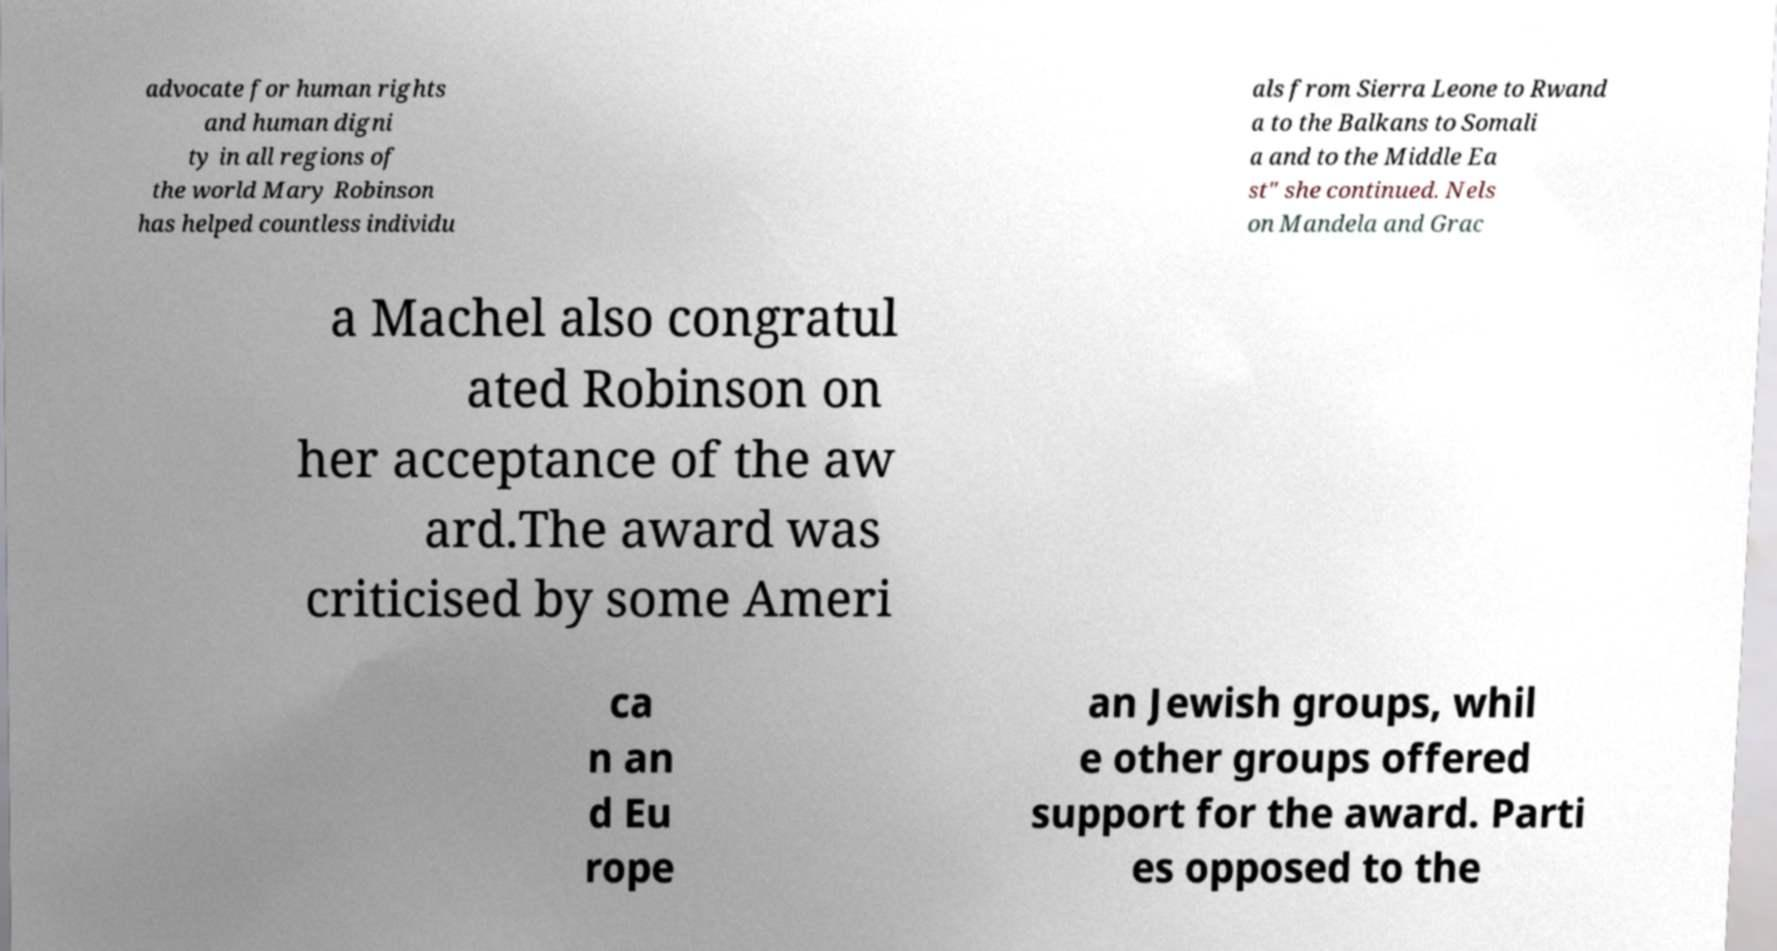Could you extract and type out the text from this image? advocate for human rights and human digni ty in all regions of the world Mary Robinson has helped countless individu als from Sierra Leone to Rwand a to the Balkans to Somali a and to the Middle Ea st" she continued. Nels on Mandela and Grac a Machel also congratul ated Robinson on her acceptance of the aw ard.The award was criticised by some Ameri ca n an d Eu rope an Jewish groups, whil e other groups offered support for the award. Parti es opposed to the 